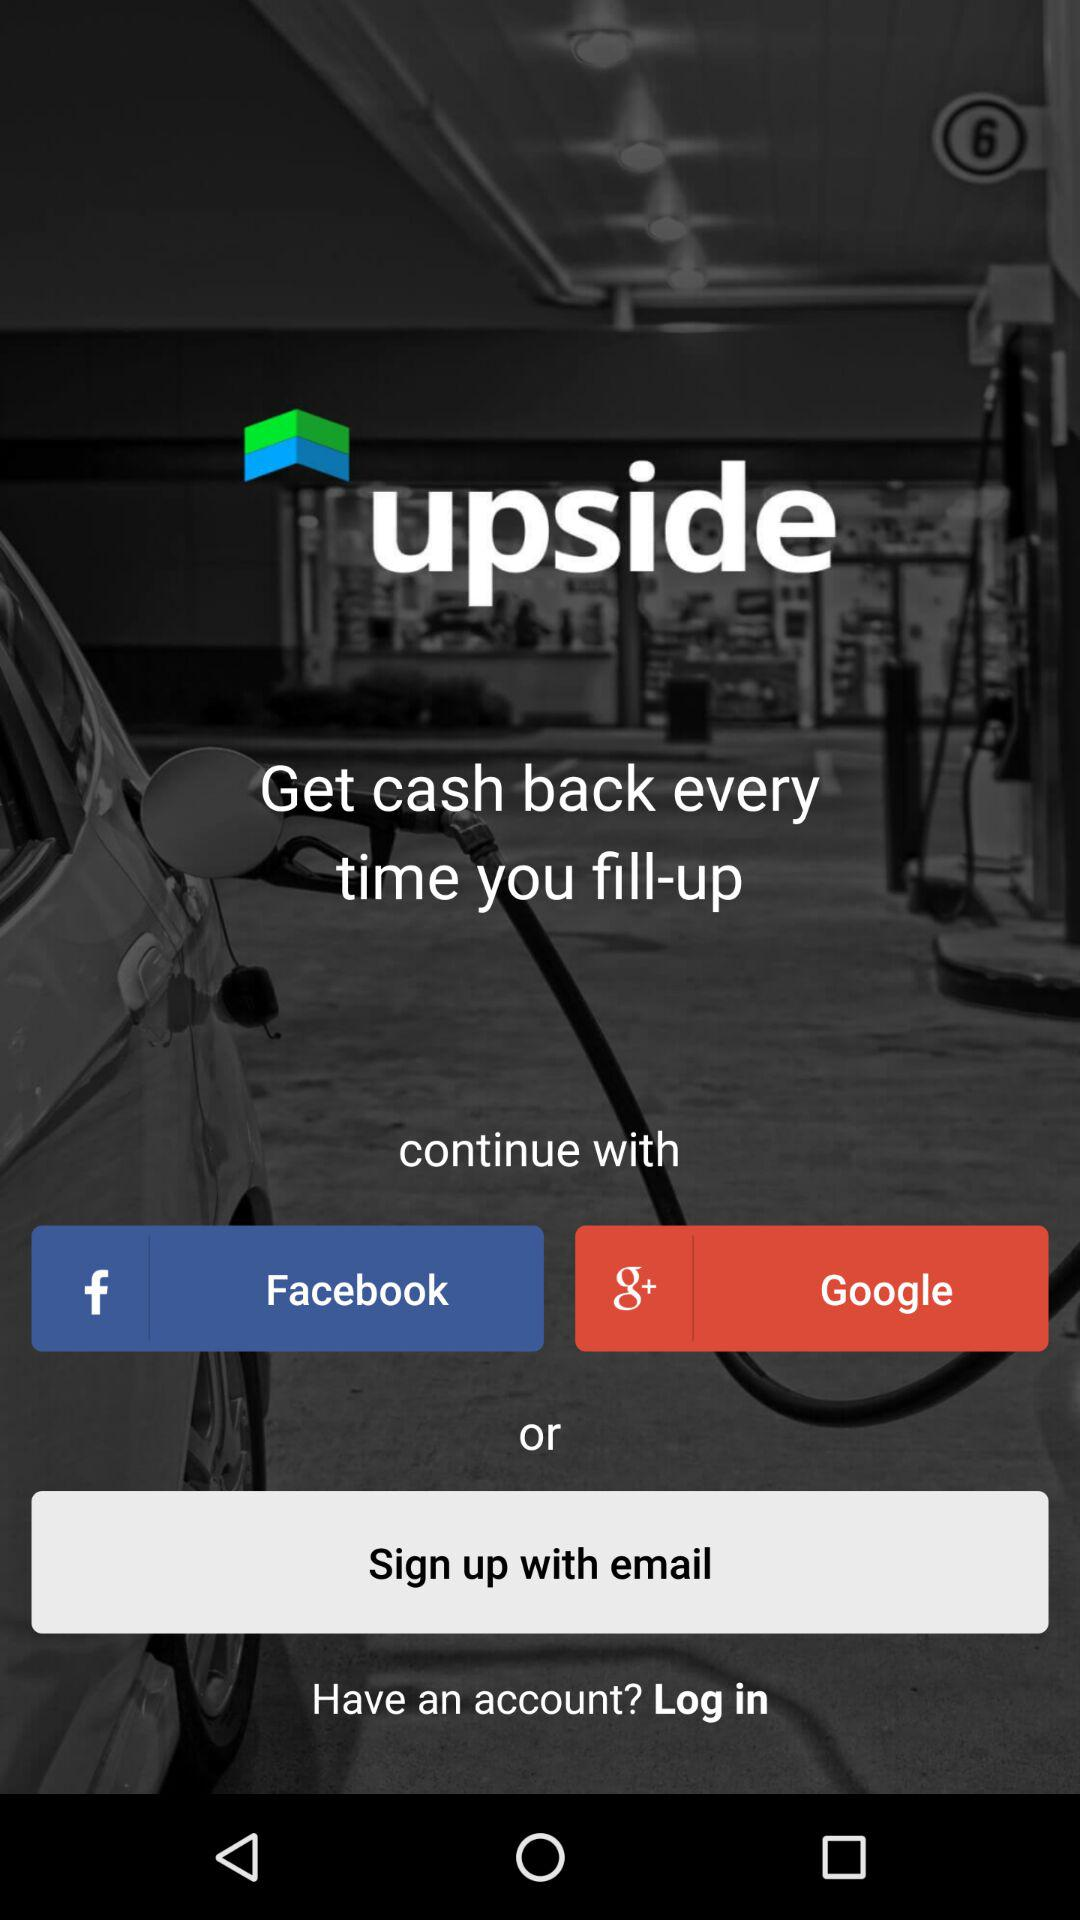What is the name of the application? The application name is "upside". 